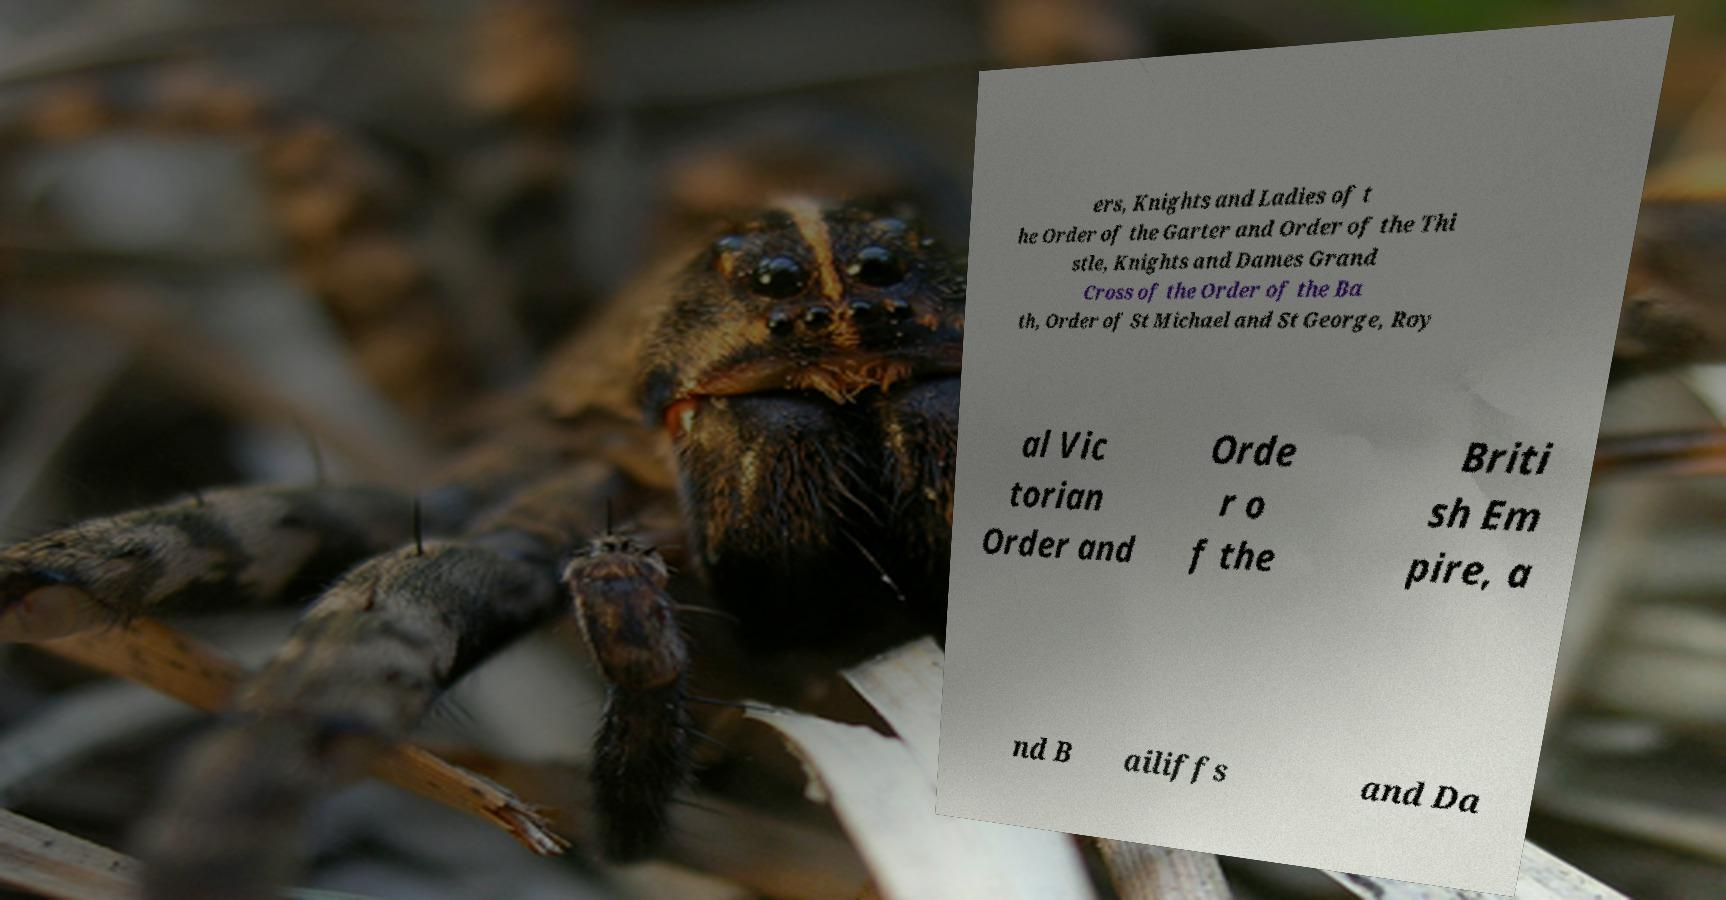Please read and relay the text visible in this image. What does it say? ers, Knights and Ladies of t he Order of the Garter and Order of the Thi stle, Knights and Dames Grand Cross of the Order of the Ba th, Order of St Michael and St George, Roy al Vic torian Order and Orde r o f the Briti sh Em pire, a nd B ailiffs and Da 